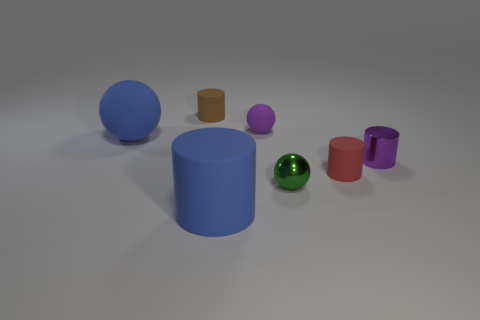Can you describe the arrangement of the objects in the image? Certainly! The image shows a variety of cylindrical objects arranged haphazardly on a flat surface. There are seven cylinders in total, each varying in size, color, and material finish. 